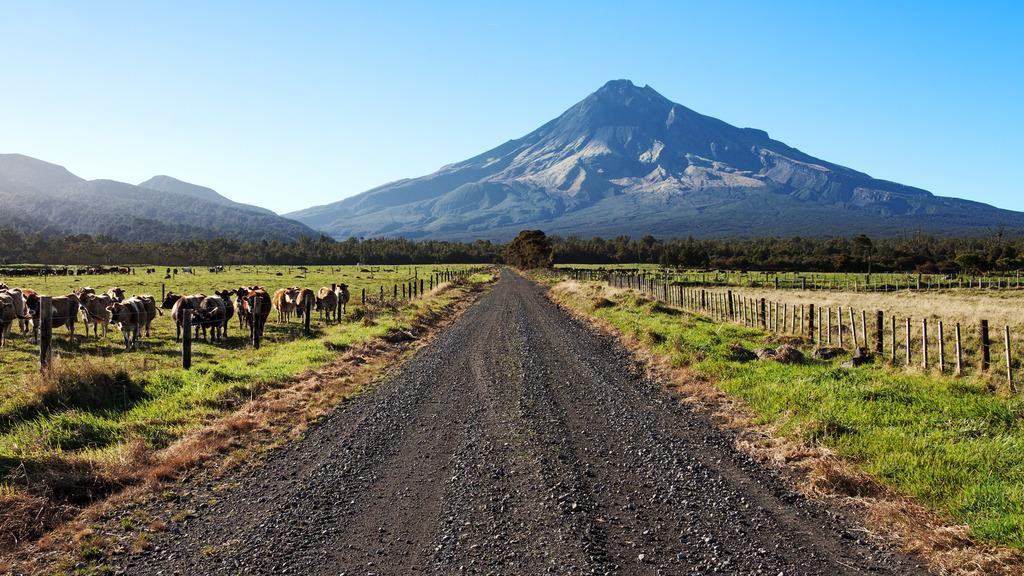In one or two sentences, can you explain what this image depicts? In this image I can see the road, some grass and few poles on both sides of the road. I can see few animals on the ground and in the background I can see few trees, few mountains and the sky. 